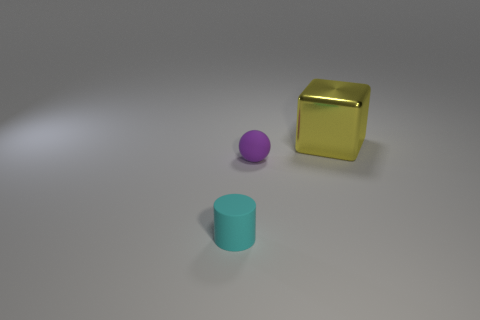What number of small matte balls are behind the small rubber thing that is in front of the small purple object?
Your answer should be compact. 1. Are there any other things that are the same shape as the yellow metallic thing?
Make the answer very short. No. Does the object that is behind the purple object have the same color as the small matte object that is to the right of the tiny cylinder?
Your response must be concise. No. Is the number of things less than the number of cyan shiny spheres?
Your answer should be very brief. No. There is a tiny rubber thing in front of the matte thing behind the small rubber cylinder; what is its shape?
Your response must be concise. Cylinder. Is there any other thing that is the same size as the cylinder?
Your answer should be very brief. Yes. The thing that is behind the tiny thing that is to the right of the object that is in front of the rubber sphere is what shape?
Give a very brief answer. Cube. How many objects are blocks to the right of the tiny purple ball or objects that are left of the large block?
Your response must be concise. 3. There is a matte cylinder; does it have the same size as the object behind the small purple ball?
Offer a terse response. No. Does the small object to the right of the cyan rubber cylinder have the same material as the object in front of the purple object?
Your answer should be very brief. Yes. 